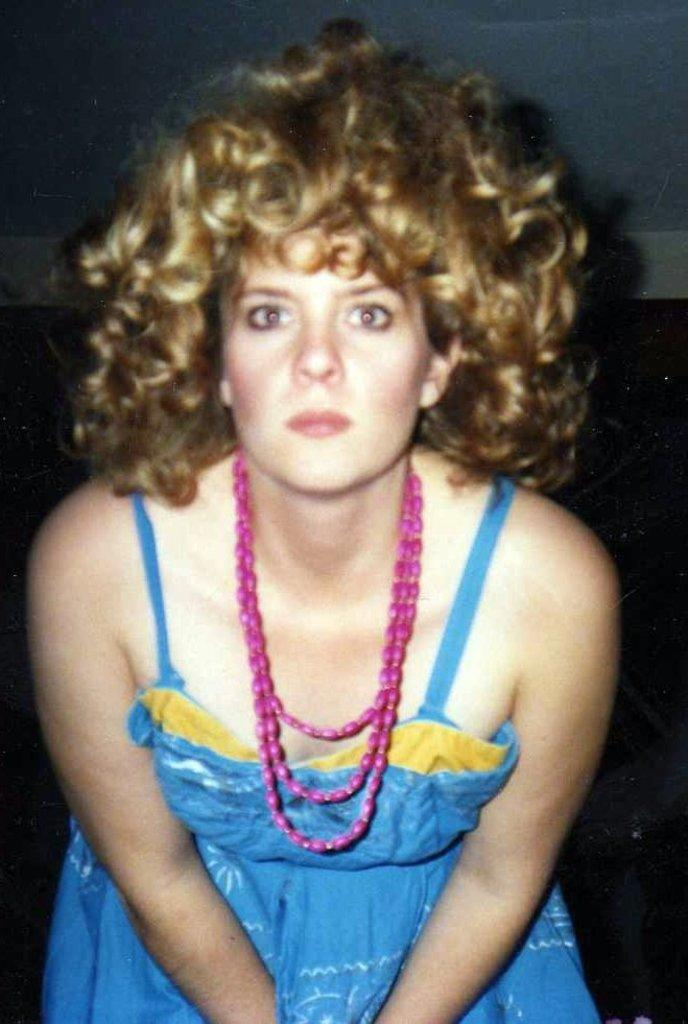Who is the main subject in the image? There is a woman in the center of the image. What is the woman wearing in the image? The woman is wearing a necklace in the image. What can be seen in the background of the image? There is a wall in the background of the image. Who is the creator of the boundary in the image? There is no boundary present in the image, so it is not possible to determine who created it. 